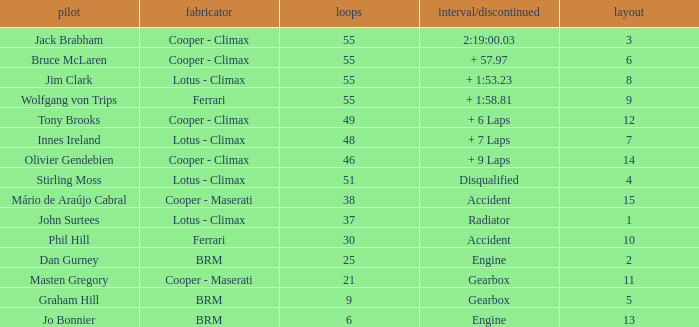Tell me the laps for 3 grids 55.0. 